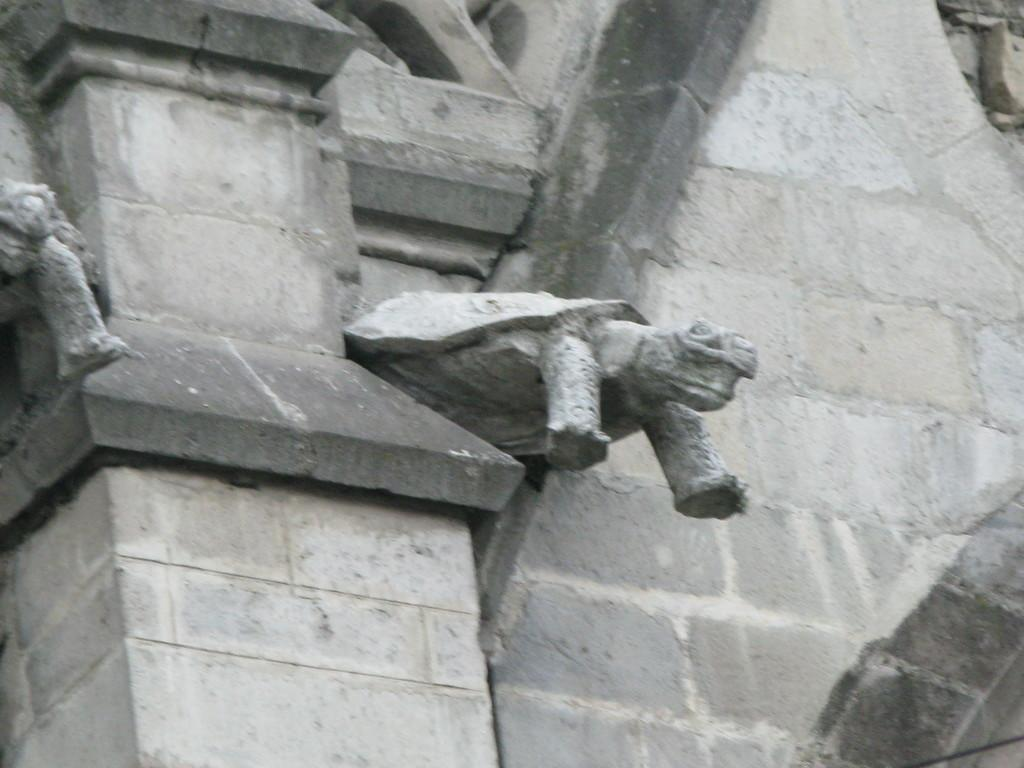What is attached to the wall in the image? There are few statues attached to the wall. What is the color of the wall in the image? The wall is in gray color. Can you tell me how many robins are perched on the statues in the image? There are no robins present in the image; it features statues attached to which are attached to the gray wall. What type of camera is used to capture the image? The provided facts do not mention any camera or photography equipment, so it cannot be determined from the image. 